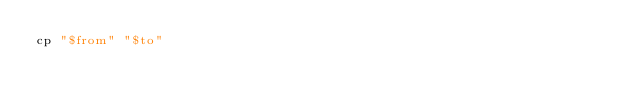<code> <loc_0><loc_0><loc_500><loc_500><_Bash_>cp "$from" "$to"
</code> 